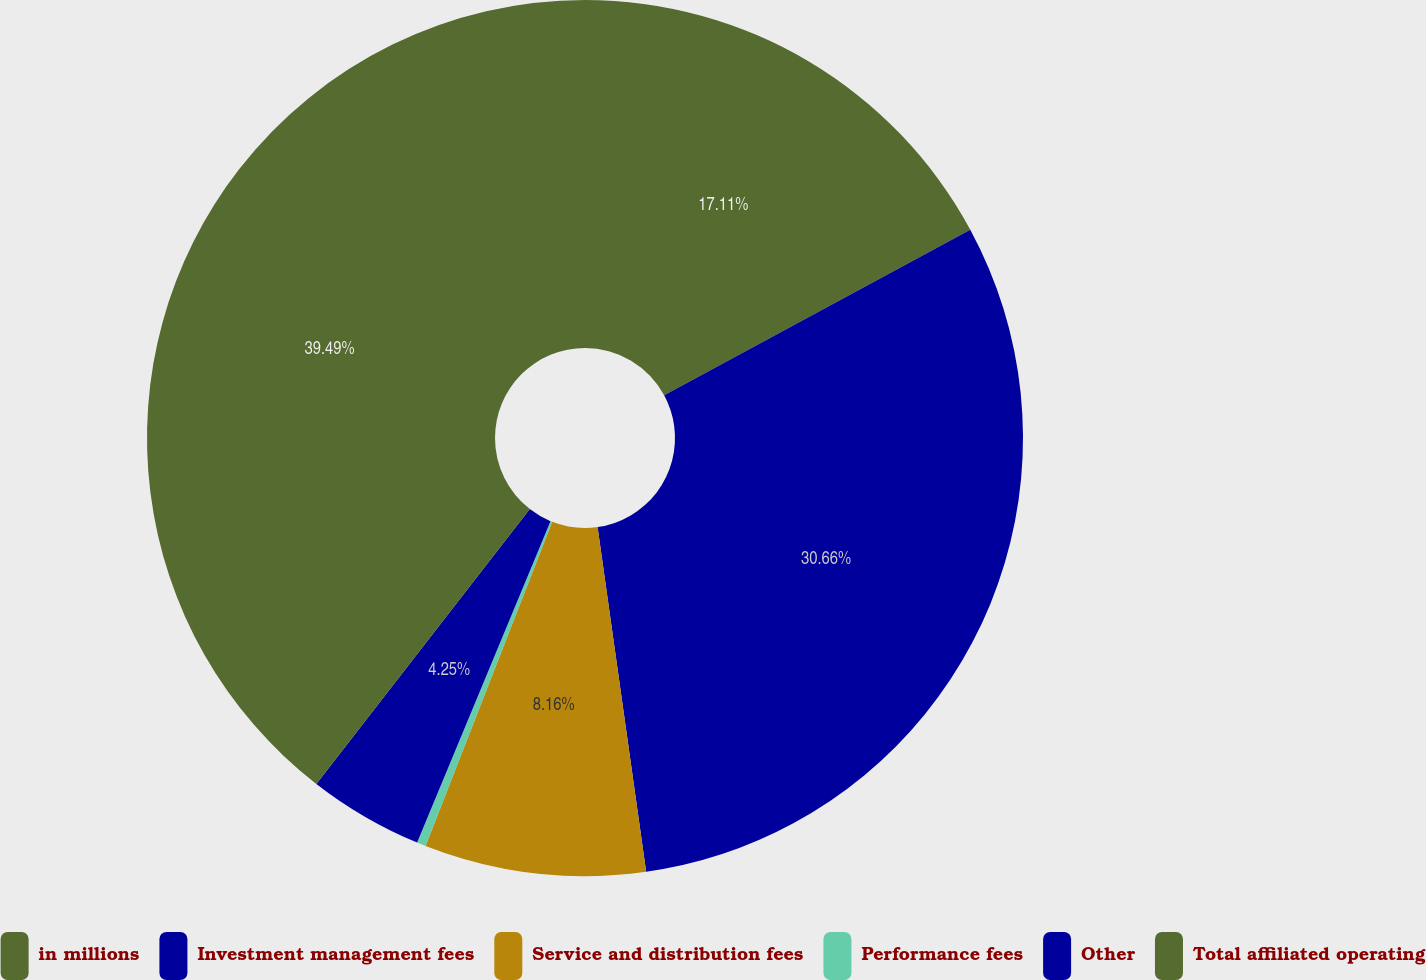Convert chart. <chart><loc_0><loc_0><loc_500><loc_500><pie_chart><fcel>in millions<fcel>Investment management fees<fcel>Service and distribution fees<fcel>Performance fees<fcel>Other<fcel>Total affiliated operating<nl><fcel>17.11%<fcel>30.66%<fcel>8.16%<fcel>0.33%<fcel>4.25%<fcel>39.49%<nl></chart> 